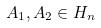Convert formula to latex. <formula><loc_0><loc_0><loc_500><loc_500>A _ { 1 } , A _ { 2 } \in H _ { n }</formula> 